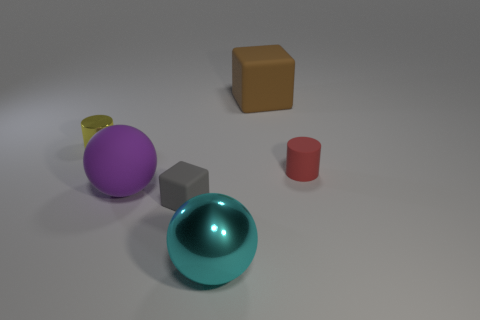Add 2 small red cylinders. How many objects exist? 8 Subtract all cylinders. How many objects are left? 4 Add 3 small red cylinders. How many small red cylinders exist? 4 Subtract 0 brown cylinders. How many objects are left? 6 Subtract all small red cylinders. Subtract all red blocks. How many objects are left? 5 Add 1 rubber balls. How many rubber balls are left? 2 